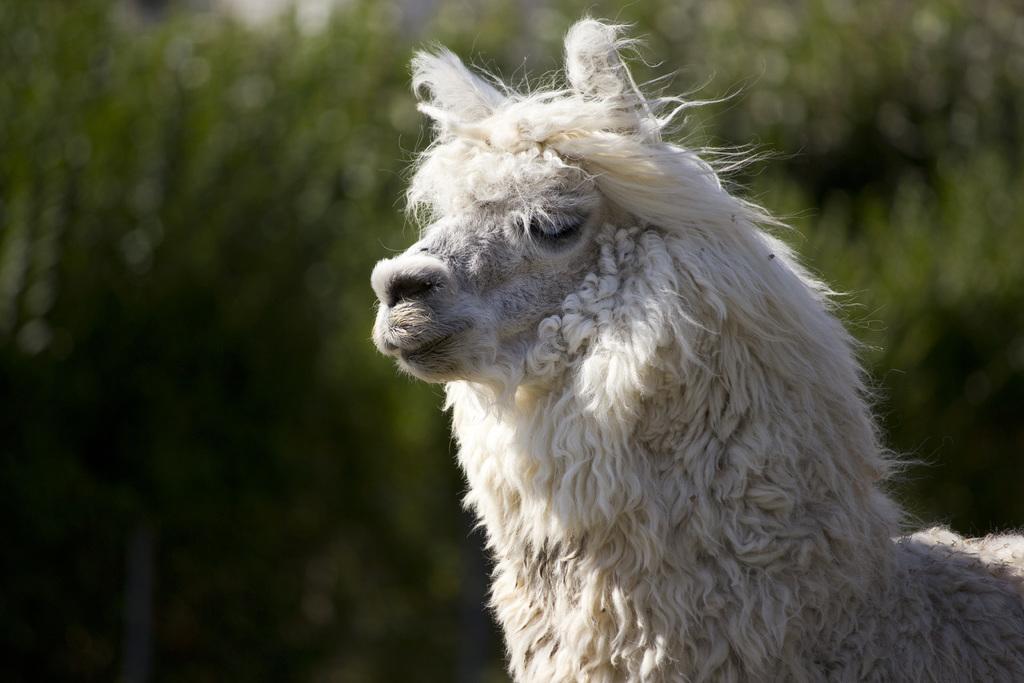Describe this image in one or two sentences. In this image, we can see an animal on the blur background. 